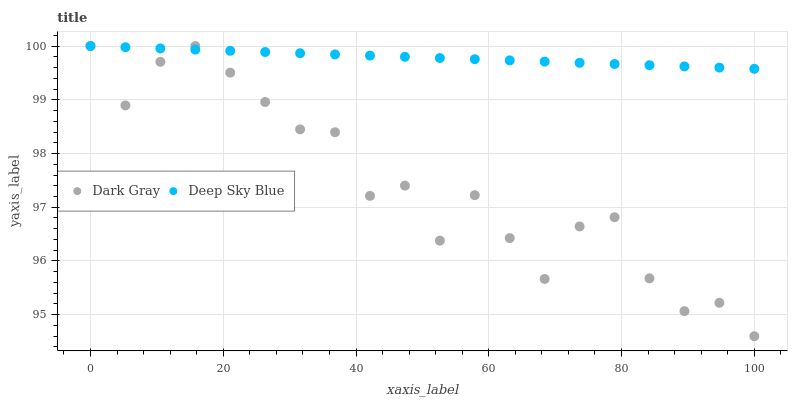Does Dark Gray have the minimum area under the curve?
Answer yes or no. Yes. Does Deep Sky Blue have the maximum area under the curve?
Answer yes or no. Yes. Does Deep Sky Blue have the minimum area under the curve?
Answer yes or no. No. Is Deep Sky Blue the smoothest?
Answer yes or no. Yes. Is Dark Gray the roughest?
Answer yes or no. Yes. Is Deep Sky Blue the roughest?
Answer yes or no. No. Does Dark Gray have the lowest value?
Answer yes or no. Yes. Does Deep Sky Blue have the lowest value?
Answer yes or no. No. Does Deep Sky Blue have the highest value?
Answer yes or no. Yes. Does Deep Sky Blue intersect Dark Gray?
Answer yes or no. Yes. Is Deep Sky Blue less than Dark Gray?
Answer yes or no. No. Is Deep Sky Blue greater than Dark Gray?
Answer yes or no. No. 